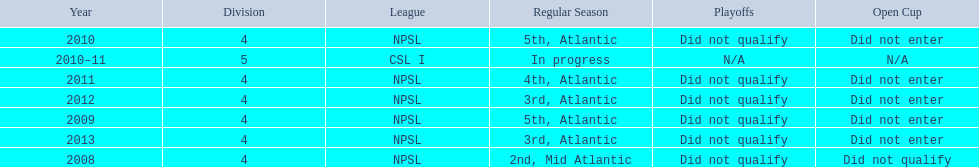What are all of the leagues? NPSL, NPSL, NPSL, CSL I, NPSL, NPSL, NPSL. Which league was played in the least? CSL I. 